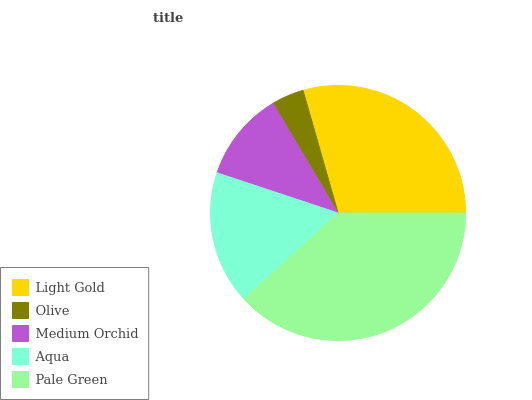Is Olive the minimum?
Answer yes or no. Yes. Is Pale Green the maximum?
Answer yes or no. Yes. Is Medium Orchid the minimum?
Answer yes or no. No. Is Medium Orchid the maximum?
Answer yes or no. No. Is Medium Orchid greater than Olive?
Answer yes or no. Yes. Is Olive less than Medium Orchid?
Answer yes or no. Yes. Is Olive greater than Medium Orchid?
Answer yes or no. No. Is Medium Orchid less than Olive?
Answer yes or no. No. Is Aqua the high median?
Answer yes or no. Yes. Is Aqua the low median?
Answer yes or no. Yes. Is Medium Orchid the high median?
Answer yes or no. No. Is Medium Orchid the low median?
Answer yes or no. No. 